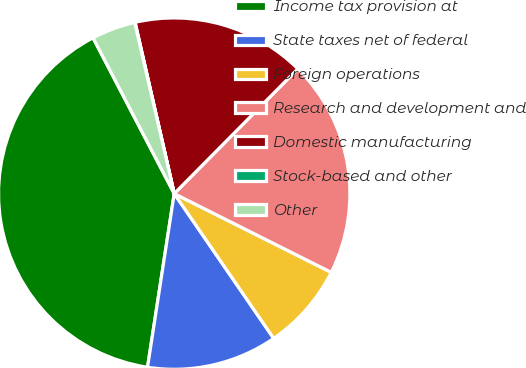Convert chart to OTSL. <chart><loc_0><loc_0><loc_500><loc_500><pie_chart><fcel>Income tax provision at<fcel>State taxes net of federal<fcel>Foreign operations<fcel>Research and development and<fcel>Domestic manufacturing<fcel>Stock-based and other<fcel>Other<nl><fcel>39.93%<fcel>12.01%<fcel>8.02%<fcel>19.98%<fcel>16.0%<fcel>0.04%<fcel>4.03%<nl></chart> 